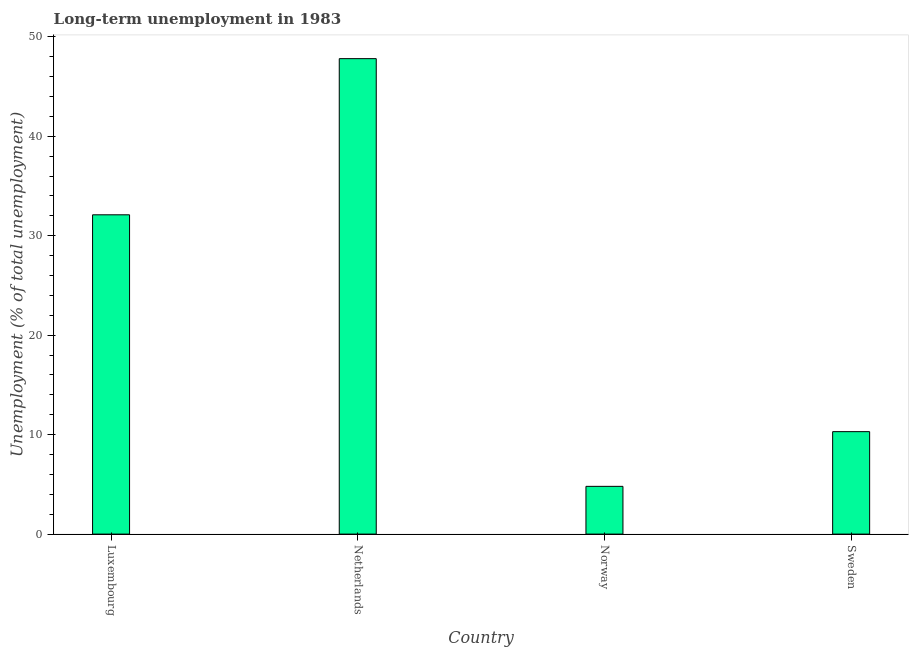Does the graph contain grids?
Keep it short and to the point. No. What is the title of the graph?
Provide a succinct answer. Long-term unemployment in 1983. What is the label or title of the Y-axis?
Make the answer very short. Unemployment (% of total unemployment). What is the long-term unemployment in Netherlands?
Your response must be concise. 47.8. Across all countries, what is the maximum long-term unemployment?
Make the answer very short. 47.8. Across all countries, what is the minimum long-term unemployment?
Offer a very short reply. 4.8. In which country was the long-term unemployment minimum?
Your answer should be compact. Norway. What is the sum of the long-term unemployment?
Offer a very short reply. 95. What is the difference between the long-term unemployment in Luxembourg and Netherlands?
Your answer should be very brief. -15.7. What is the average long-term unemployment per country?
Your response must be concise. 23.75. What is the median long-term unemployment?
Your answer should be compact. 21.2. What is the ratio of the long-term unemployment in Luxembourg to that in Norway?
Provide a succinct answer. 6.69. What is the difference between the highest and the lowest long-term unemployment?
Give a very brief answer. 43. How many bars are there?
Give a very brief answer. 4. Are all the bars in the graph horizontal?
Keep it short and to the point. No. How many countries are there in the graph?
Your response must be concise. 4. What is the difference between two consecutive major ticks on the Y-axis?
Keep it short and to the point. 10. Are the values on the major ticks of Y-axis written in scientific E-notation?
Your response must be concise. No. What is the Unemployment (% of total unemployment) of Luxembourg?
Ensure brevity in your answer.  32.1. What is the Unemployment (% of total unemployment) of Netherlands?
Provide a succinct answer. 47.8. What is the Unemployment (% of total unemployment) in Norway?
Ensure brevity in your answer.  4.8. What is the Unemployment (% of total unemployment) in Sweden?
Your answer should be compact. 10.3. What is the difference between the Unemployment (% of total unemployment) in Luxembourg and Netherlands?
Your response must be concise. -15.7. What is the difference between the Unemployment (% of total unemployment) in Luxembourg and Norway?
Make the answer very short. 27.3. What is the difference between the Unemployment (% of total unemployment) in Luxembourg and Sweden?
Give a very brief answer. 21.8. What is the difference between the Unemployment (% of total unemployment) in Netherlands and Sweden?
Make the answer very short. 37.5. What is the ratio of the Unemployment (% of total unemployment) in Luxembourg to that in Netherlands?
Provide a succinct answer. 0.67. What is the ratio of the Unemployment (% of total unemployment) in Luxembourg to that in Norway?
Your response must be concise. 6.69. What is the ratio of the Unemployment (% of total unemployment) in Luxembourg to that in Sweden?
Make the answer very short. 3.12. What is the ratio of the Unemployment (% of total unemployment) in Netherlands to that in Norway?
Keep it short and to the point. 9.96. What is the ratio of the Unemployment (% of total unemployment) in Netherlands to that in Sweden?
Offer a terse response. 4.64. What is the ratio of the Unemployment (% of total unemployment) in Norway to that in Sweden?
Ensure brevity in your answer.  0.47. 